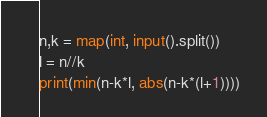Convert code to text. <code><loc_0><loc_0><loc_500><loc_500><_Python_>n,k = map(int, input().split())
l = n//k
print(min(n-k*l, abs(n-k*(l+1))))</code> 